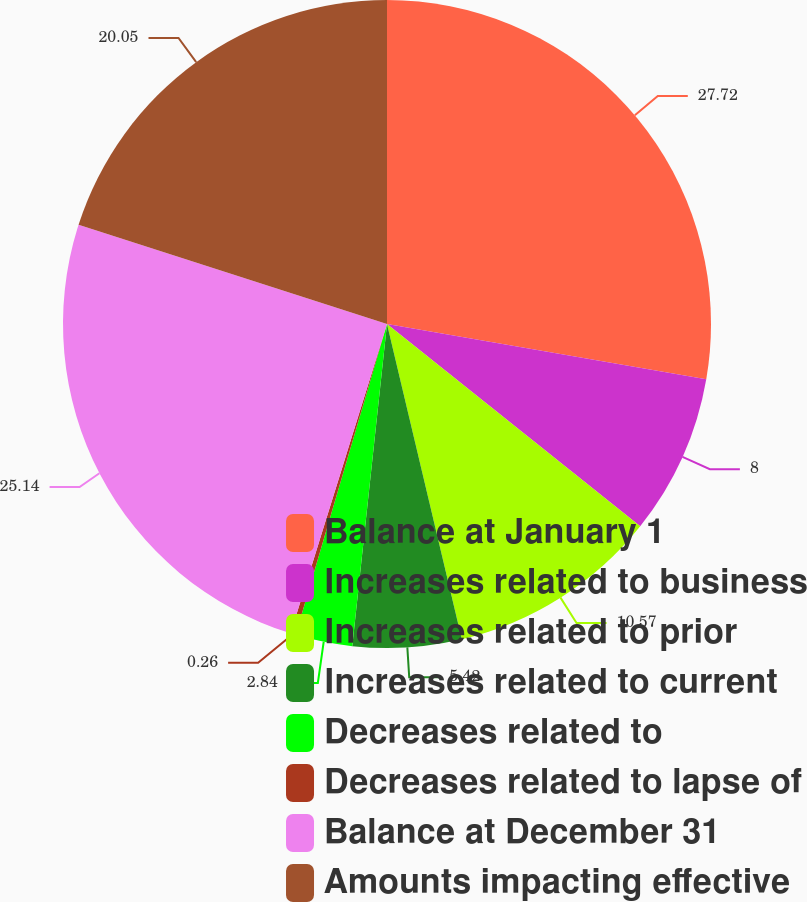Convert chart to OTSL. <chart><loc_0><loc_0><loc_500><loc_500><pie_chart><fcel>Balance at January 1<fcel>Increases related to business<fcel>Increases related to prior<fcel>Increases related to current<fcel>Decreases related to<fcel>Decreases related to lapse of<fcel>Balance at December 31<fcel>Amounts impacting effective<nl><fcel>27.73%<fcel>8.0%<fcel>10.57%<fcel>5.42%<fcel>2.84%<fcel>0.26%<fcel>25.15%<fcel>20.05%<nl></chart> 